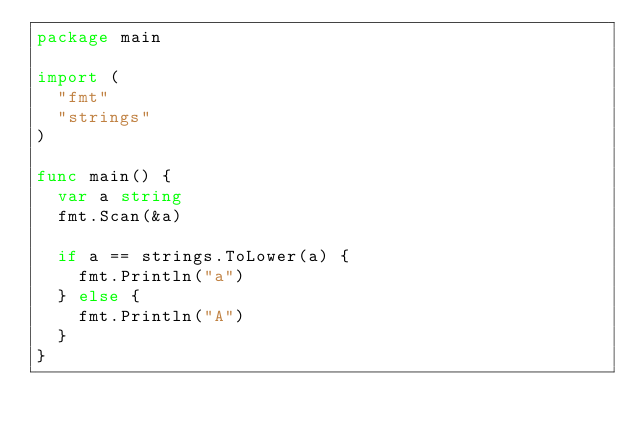Convert code to text. <code><loc_0><loc_0><loc_500><loc_500><_Go_>package main

import (
	"fmt"
	"strings"
)

func main() {
	var a string
	fmt.Scan(&a)

	if a == strings.ToLower(a) {
		fmt.Println("a")
	} else {
		fmt.Println("A")
	}
}
</code> 